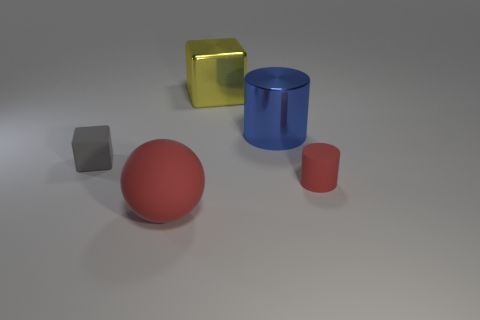What material is the blue cylinder left of the cylinder in front of the small gray rubber thing made of?
Ensure brevity in your answer.  Metal. Are there any tiny gray objects of the same shape as the large blue thing?
Make the answer very short. No. How many other things are the same shape as the large blue thing?
Keep it short and to the point. 1. There is a matte thing that is behind the big red matte sphere and on the left side of the big cube; what shape is it?
Make the answer very short. Cube. What size is the cube that is right of the ball?
Provide a short and direct response. Large. Do the rubber cylinder and the gray rubber thing have the same size?
Ensure brevity in your answer.  Yes. Are there fewer large blue shiny cylinders that are in front of the small gray thing than rubber balls in front of the tiny cylinder?
Your answer should be compact. Yes. There is a rubber thing that is right of the small gray rubber block and behind the large ball; what is its size?
Provide a short and direct response. Small. Are there any small rubber cylinders in front of the red thing that is behind the red thing that is in front of the tiny rubber cylinder?
Keep it short and to the point. No. Is there a tiny cyan cylinder?
Offer a very short reply. No. 